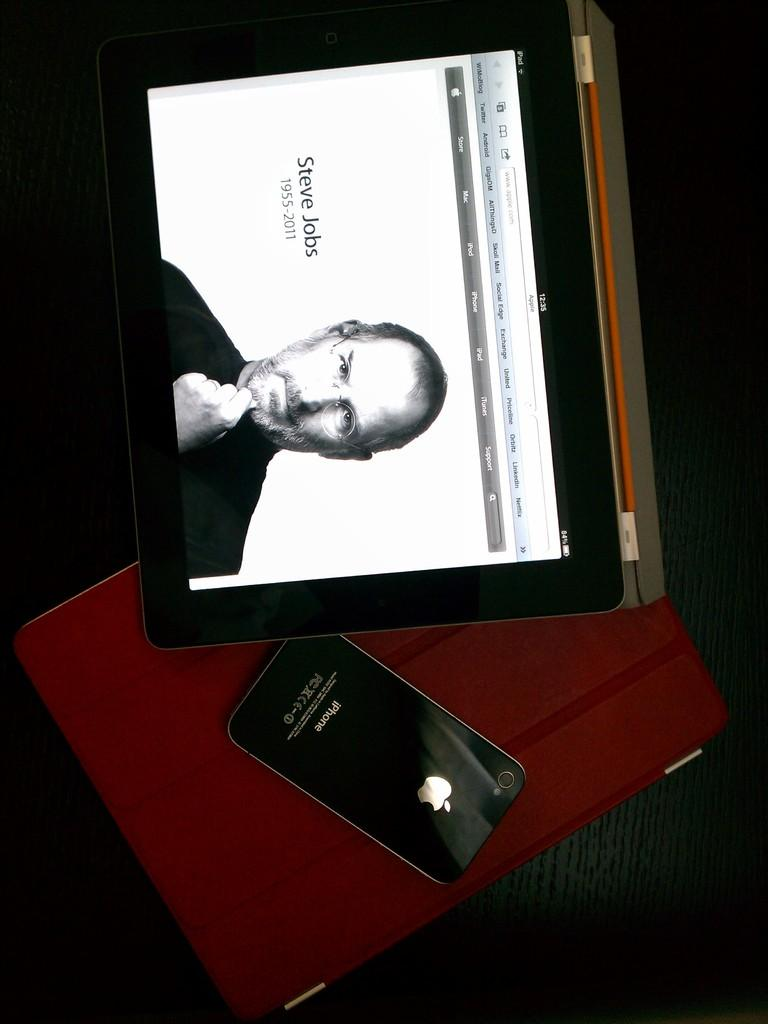<image>
Present a compact description of the photo's key features. iPhone next to an iPad that shows the screen of Steve Jobs. 